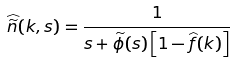<formula> <loc_0><loc_0><loc_500><loc_500>\widehat { \widetilde { n } } ( k , s ) = \frac { 1 } { s + \widetilde { \phi } ( s ) \left [ 1 - \widehat { f } ( k ) \right ] }</formula> 